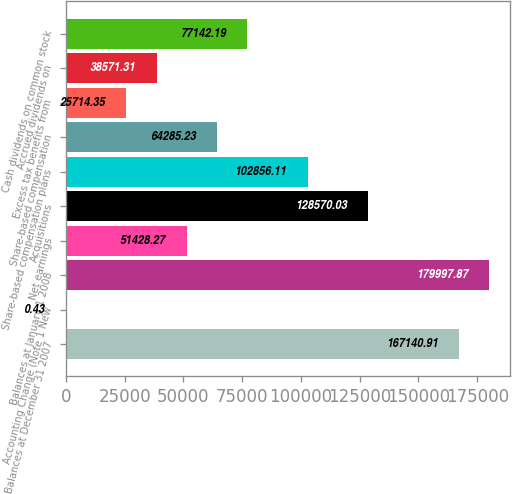Convert chart. <chart><loc_0><loc_0><loc_500><loc_500><bar_chart><fcel>Balances at December 31 2007<fcel>Accounting Change (Note 1 New<fcel>Balances at January 1 2008<fcel>Net earnings<fcel>Acquisitions<fcel>Share-based compensation plans<fcel>Share-based compensation<fcel>Excess tax benefits from<fcel>Accrued dividends on<fcel>Cash dividends on common stock<nl><fcel>167141<fcel>0.43<fcel>179998<fcel>51428.3<fcel>128570<fcel>102856<fcel>64285.2<fcel>25714.3<fcel>38571.3<fcel>77142.2<nl></chart> 